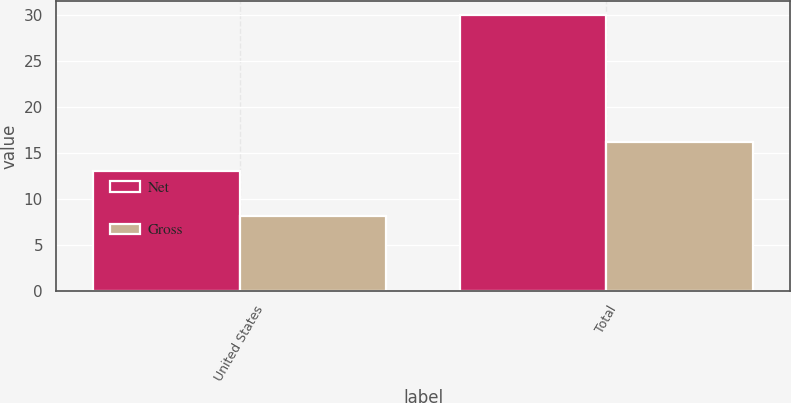Convert chart to OTSL. <chart><loc_0><loc_0><loc_500><loc_500><stacked_bar_chart><ecel><fcel>United States<fcel>Total<nl><fcel>Net<fcel>13<fcel>30<nl><fcel>Gross<fcel>8.1<fcel>16.2<nl></chart> 